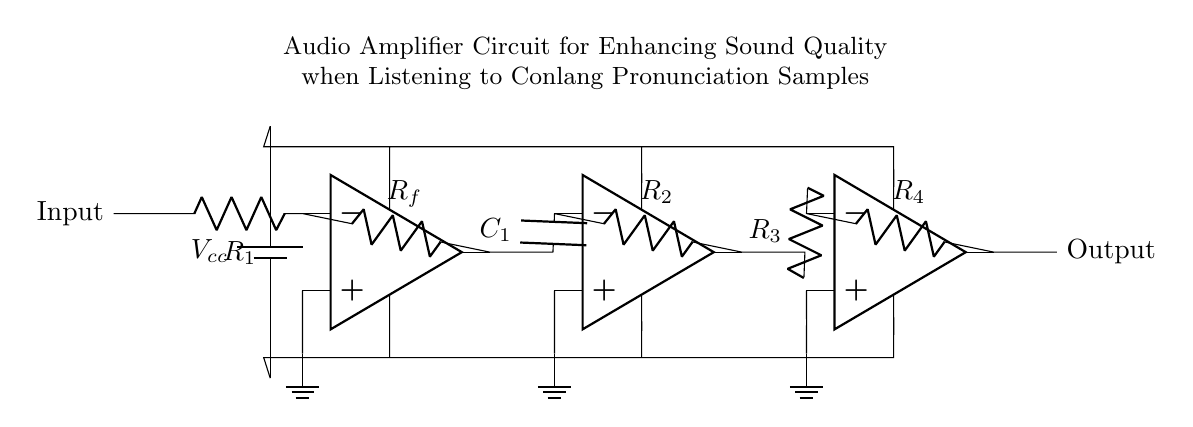What is the type of circuit shown? The circuit is an audio amplifier circuit, as indicated by the presence of operational amplifiers and the purpose mentioned in the title.
Answer: audio amplifier How many operational amplifiers are in the circuit? The diagram shows three operational amplifiers connected in series for amplification.
Answer: three What is the value of the first resistor labeled in the diagram? The first resistor is labeled as R one, and while the exact numerical value isn't provided in the diagram, it is commonly used for input in such circuits.
Answer: R one What is the purpose of the capacitor in this circuit? The capacitor is typically used for filtering or coupling signals to enhance sound quality, acting as a high-pass filter in this context.
Answer: filtering Which component connects the output of the first op-amp to the input of the second op-amp? The connection is made via a capacitor that allows the signal to pass while blocking DC components, thus ensuring an appropriate signal for amplification.
Answer: capacitor What does R four do in this circuit? R four functions as a load resistor in the output stage, helping to control the output signal level and assist in delivering power to the load.
Answer: load resistor What happens at the output of the circuit? The output provides an amplified audio signal for playback, strengthening the sound quality of conlang pronunciation samples.
Answer: amplified audio signal 